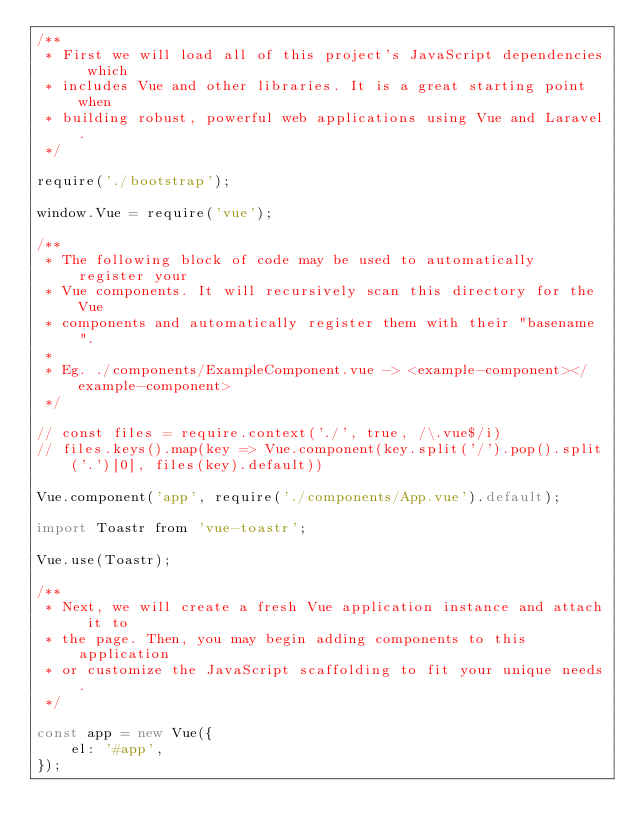Convert code to text. <code><loc_0><loc_0><loc_500><loc_500><_JavaScript_>/**
 * First we will load all of this project's JavaScript dependencies which
 * includes Vue and other libraries. It is a great starting point when
 * building robust, powerful web applications using Vue and Laravel.
 */

require('./bootstrap');

window.Vue = require('vue');

/**
 * The following block of code may be used to automatically register your
 * Vue components. It will recursively scan this directory for the Vue
 * components and automatically register them with their "basename".
 *
 * Eg. ./components/ExampleComponent.vue -> <example-component></example-component>
 */

// const files = require.context('./', true, /\.vue$/i)
// files.keys().map(key => Vue.component(key.split('/').pop().split('.')[0], files(key).default))

Vue.component('app', require('./components/App.vue').default);

import Toastr from 'vue-toastr';

Vue.use(Toastr);

/**
 * Next, we will create a fresh Vue application instance and attach it to
 * the page. Then, you may begin adding components to this application
 * or customize the JavaScript scaffolding to fit your unique needs.
 */

const app = new Vue({
    el: '#app',
});


</code> 